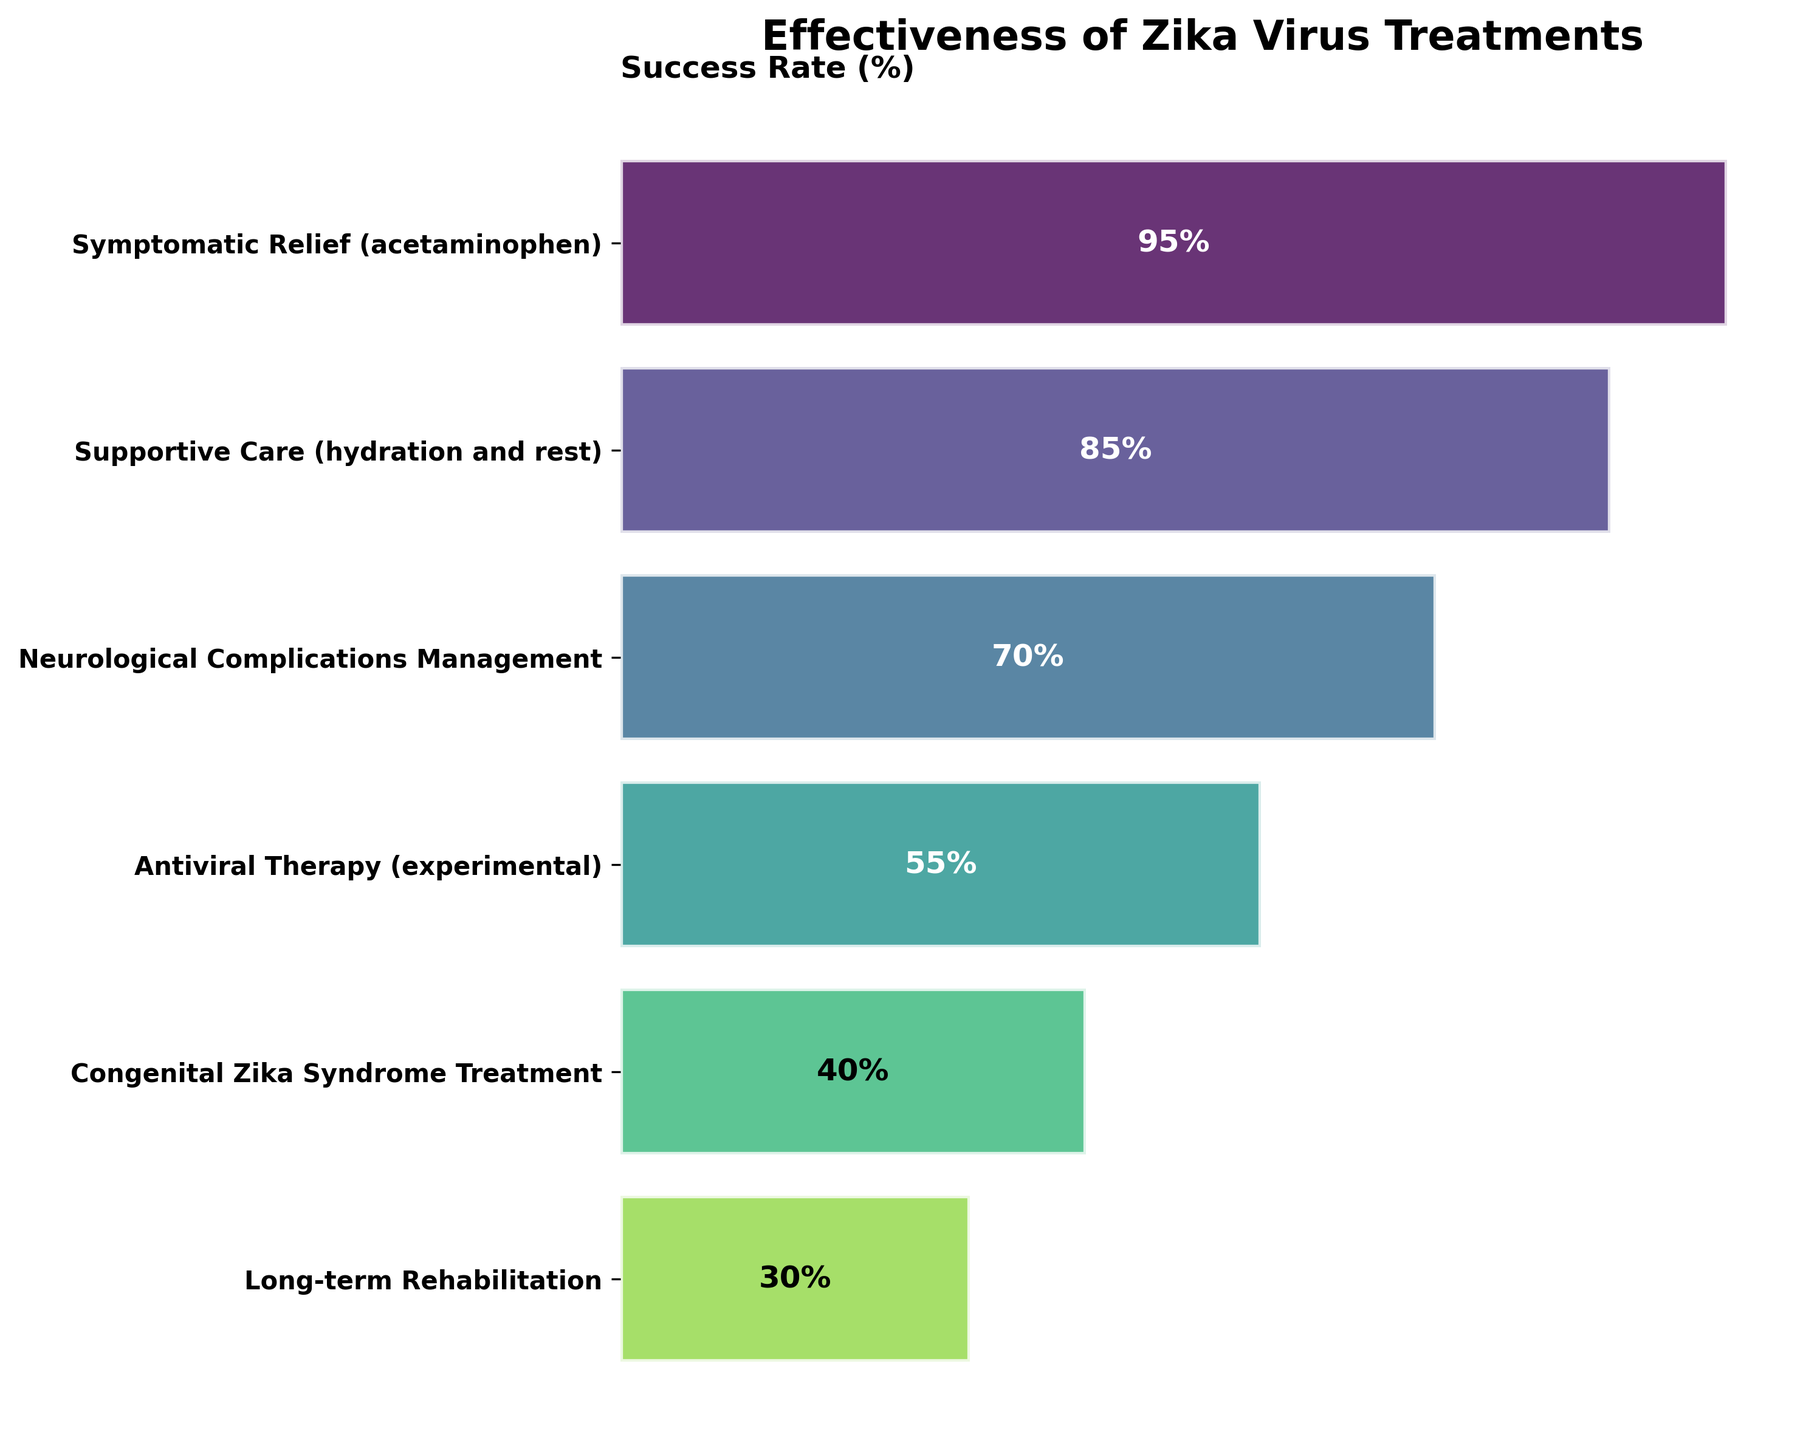What is the title of the funnel chart? The title of the chart is usually located at the top. It summarizes the main focus of the chart.
Answer: Effectiveness of Zika Virus Treatments Which treatment has the highest success rate? The topmost bar in the funnel chart represents the highest success rate, and the treatment name can be read from the corresponding y-axis label.
Answer: Symptomatic Relief (acetaminophen) Which treatment has the lowest success rate? The bottom-most bar in the funnel chart represents the lowest success rate, and the treatment name can be read from the corresponding y-axis label.
Answer: Long-term Rehabilitation What is the success rate of Supportive Care (hydration and rest)? Find the bar labeled "Supportive Care (hydration and rest)" and read the value indicated in the middle of the bar.
Answer: 85% How many treatments have a success rate above 50%? Identify and count the bars in the funnel chart whose success rates are above the 50% mark.
Answer: 3 What is the average success rate of all treatments? Sum all the success rates and divide by the number of treatments to find the average. (95 + 85 + 70 + 55 + 40 + 30) / 6 = 375 / 6 = 62.5
Answer: 62.5 Which treatment has a success rate closest to 50%? Locate the bars closest to the 50% mark and identify the one that is nearest.
Answer: Antiviral Therapy (experimental) What is the difference in success rate between the most and least effective treatments? Subtract the success rate of the least effective treatment from the most effective one. 95% - 30% = 65%
Answer: 65 Is Neurological Complications Management more effective than Supportive Care (hydration and rest)? Compare the success rates of the two treatments directly by looking at their bars.
Answer: No Which treatment is more effective, Congenital Zika Syndrome Treatment or Antiviral Therapy (experimental)? Compare the lengths of the bars representing these two treatments to determine which one is greater.
Answer: Antiviral Therapy (experimental) 